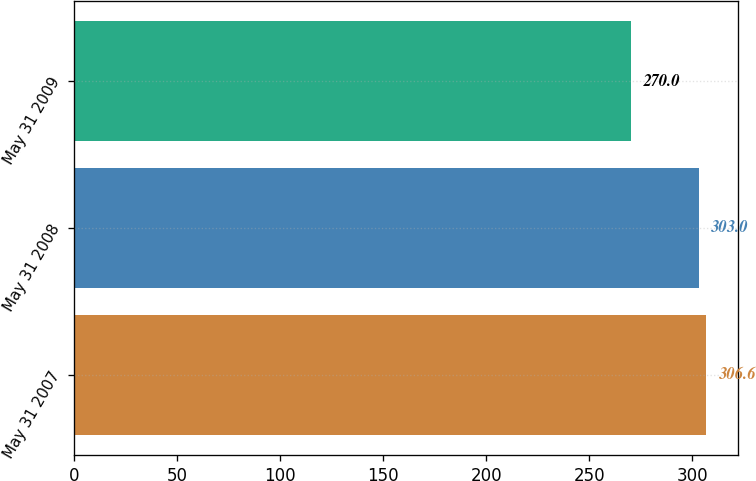Convert chart. <chart><loc_0><loc_0><loc_500><loc_500><bar_chart><fcel>May 31 2007<fcel>May 31 2008<fcel>May 31 2009<nl><fcel>306.6<fcel>303<fcel>270<nl></chart> 